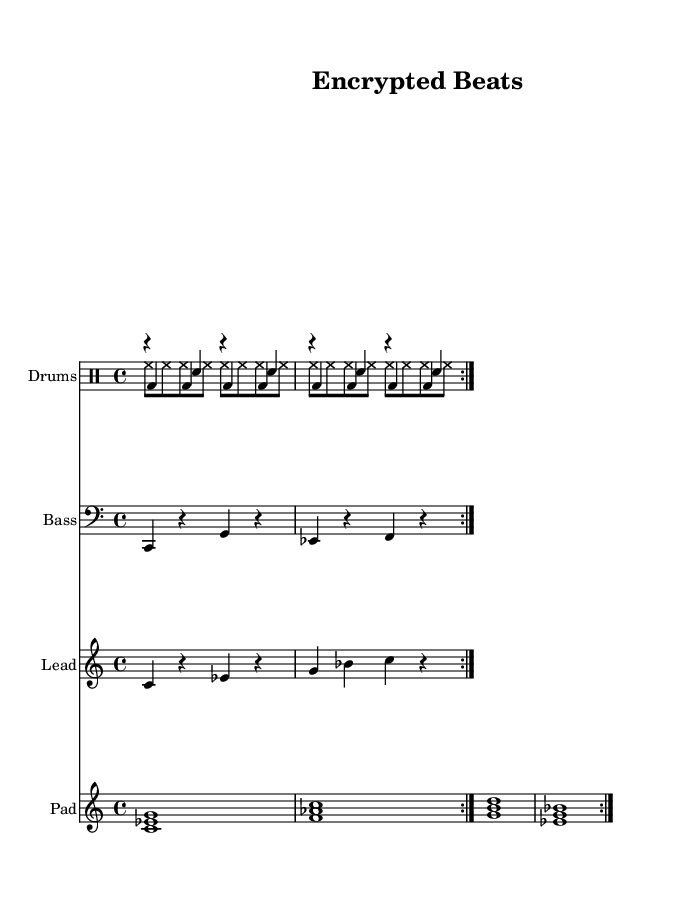What is the key signature of this music? The key signature is indicated at the beginning of the score. It is set to C minor, which has three flats (B flat, E flat, and A flat).
Answer: C minor What is the time signature of this music? The time signature is presented at the start of the staff. It shows there are four beats in each measure, indicated by the 4/4 notation.
Answer: 4/4 What is the tempo marking for this piece? The tempo marking appears above the score, indicating the speed of the music. It states 4 beats per minute, with the number showing a tempo of 128.
Answer: 128 How many measures are in the kick drum pattern? The kick drum pattern is repeated twice, and each repeat contains 8 measures, so you multiply the repeats by the measures per repeat to find the total.
Answer: 16 Which drum voice plays on the second beat of the first measure? You can find this by looking at the drum pattern for the kick drum; the second beat is occupied by a rest, indicated by "r", meaning no sound is played.
Answer: Rest How many unique instruments are included in this score? The score consists of four distinct instrument voices: drums, bass, lead synth, and pad synth. Counting those gives the total count of unique instruments present.
Answer: 4 What two notes are the bass synth playing in the first repeat? By examining the bass synth line in the first repeat, it consists of two notes playing in alternating quarter notes: C and G.
Answer: C and G 